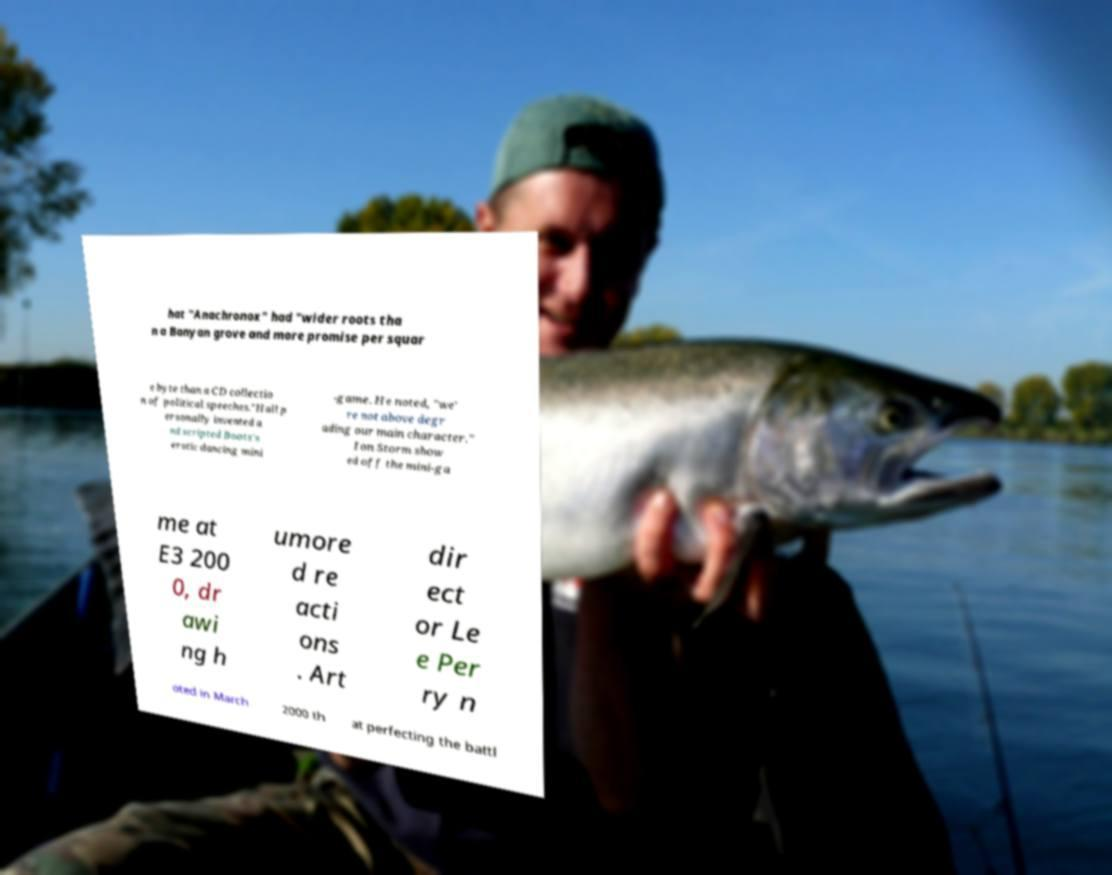Can you accurately transcribe the text from the provided image for me? hat "Anachronox" had "wider roots tha n a Banyan grove and more promise per squar e byte than a CD collectio n of political speeches."Hall p ersonally invented a nd scripted Boots's erotic dancing mini -game. He noted, "we' re not above degr ading our main character." Ion Storm show ed off the mini-ga me at E3 200 0, dr awi ng h umore d re acti ons . Art dir ect or Le e Per ry n oted in March 2000 th at perfecting the battl 